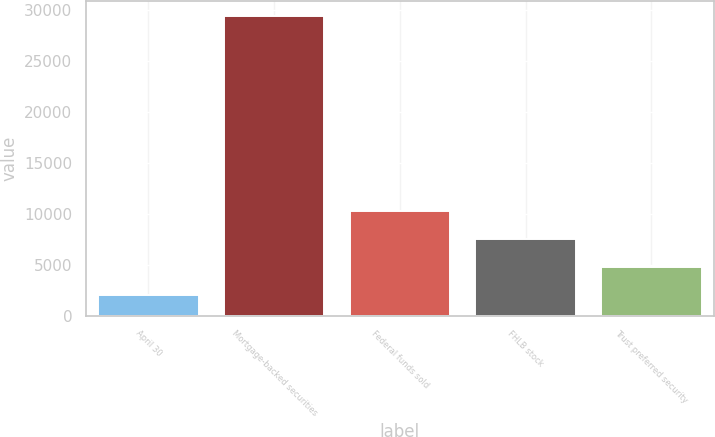<chart> <loc_0><loc_0><loc_500><loc_500><bar_chart><fcel>April 30<fcel>Mortgage-backed securities<fcel>Federal funds sold<fcel>FHLB stock<fcel>Trust preferred security<nl><fcel>2008<fcel>29401<fcel>10275.3<fcel>7536<fcel>4747.3<nl></chart> 